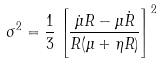<formula> <loc_0><loc_0><loc_500><loc_500>\sigma ^ { 2 } = \frac { 1 } { 3 } \left [ \frac { \dot { \mu } R - \mu \dot { R } } { R ( \mu + \eta R ) } \right ] ^ { 2 }</formula> 